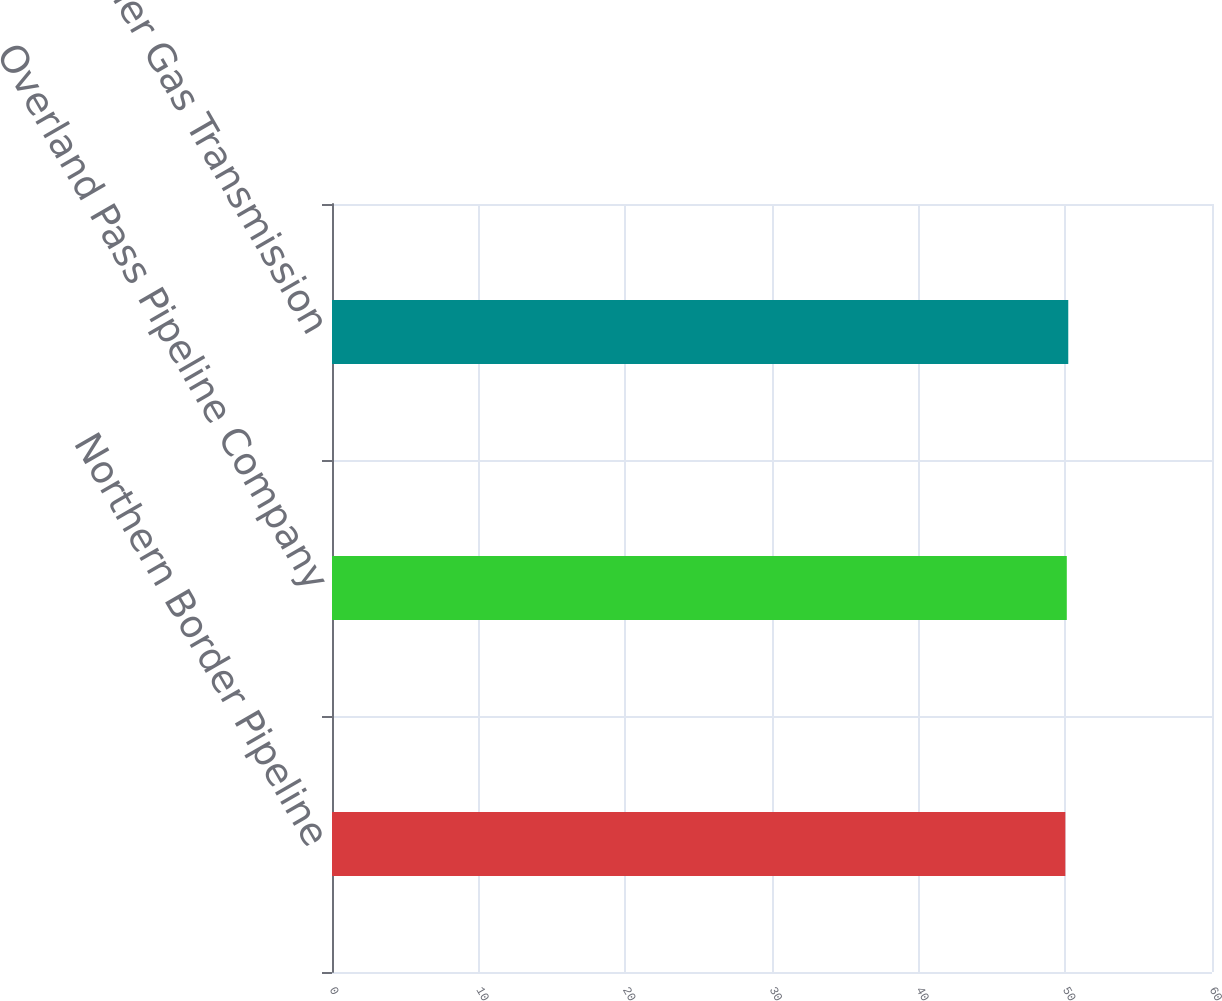<chart> <loc_0><loc_0><loc_500><loc_500><bar_chart><fcel>Northern Border Pipeline<fcel>Overland Pass Pipeline Company<fcel>Roadrunner Gas Transmission<nl><fcel>50<fcel>50.1<fcel>50.2<nl></chart> 